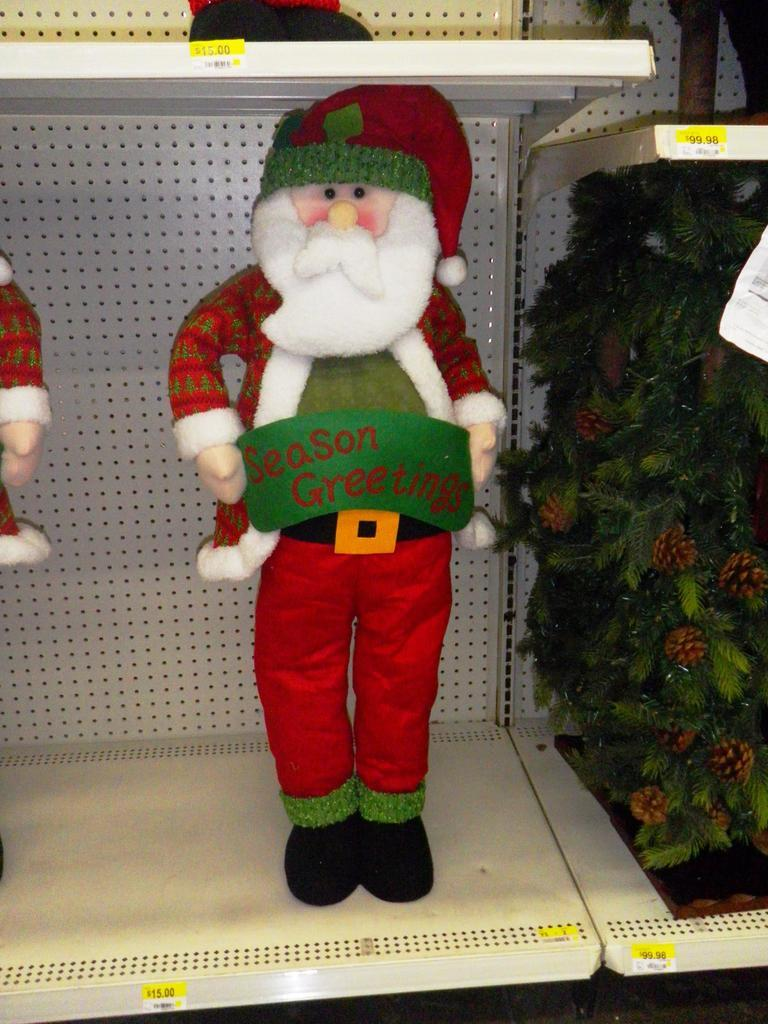<image>
Render a clear and concise summary of the photo. A santa wearing a red green and white hat while holding the sign season greetings. 